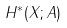<formula> <loc_0><loc_0><loc_500><loc_500>H ^ { * } ( X ; A )</formula> 